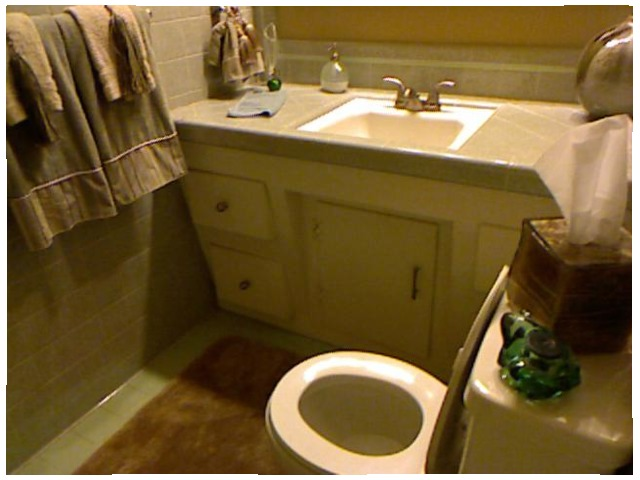<image>
Is the cabinet behind the toilet? Yes. From this viewpoint, the cabinet is positioned behind the toilet, with the toilet partially or fully occluding the cabinet. Is there a water in the toilet? Yes. The water is contained within or inside the toilet, showing a containment relationship. Is the frog in the toilet bowl? No. The frog is not contained within the toilet bowl. These objects have a different spatial relationship. Is the soap in the toilet? No. The soap is not contained within the toilet. These objects have a different spatial relationship. 